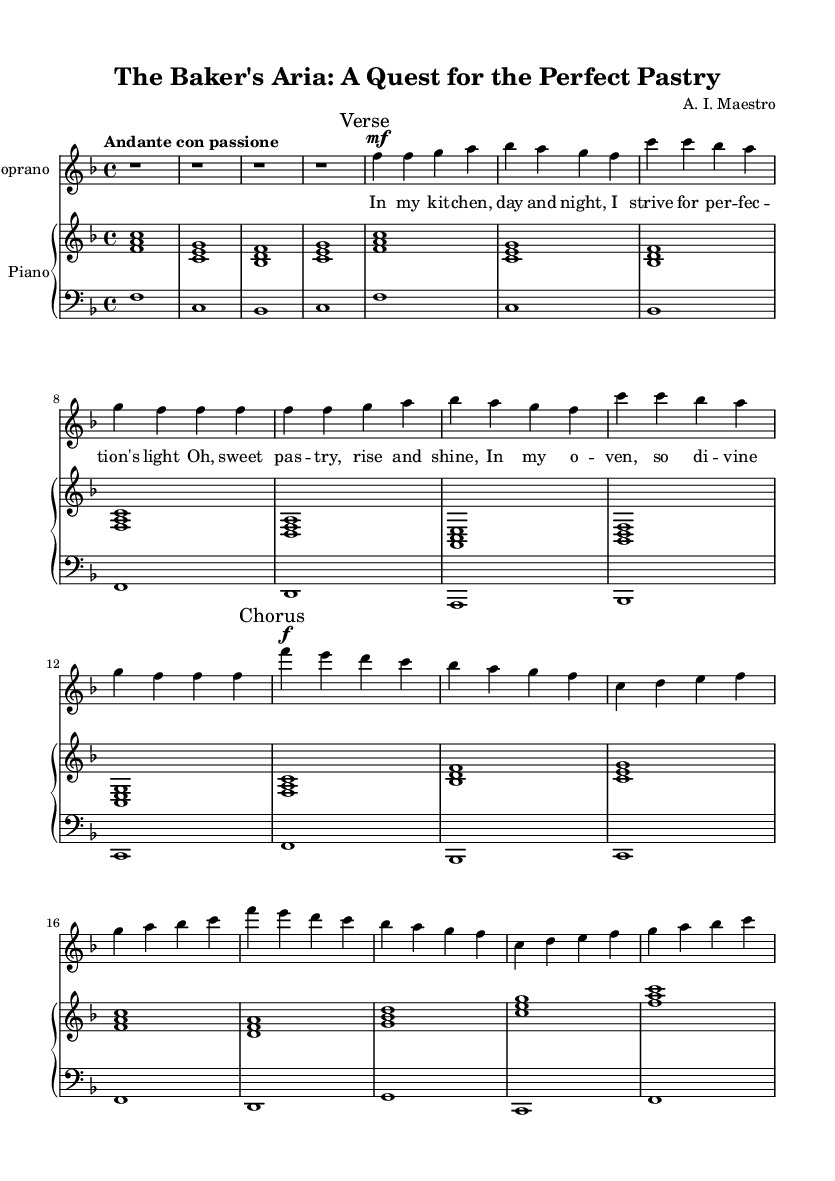What is the key signature of this music? The key signature can be found at the beginning of the sheet music, indicating F major, which has one flat (B flat).
Answer: F major What is the time signature of this music? The time signature is shown at the beginning of the piece and is indicated as 4/4, meaning there are four beats in each measure.
Answer: 4/4 What is the tempo marking of this music? The tempo marking "Andante con passione" is written above the staff, signaling that the piece should be played at a moderate speed with passion.
Answer: Andante con passione How many verses are present in the sheet music? By observing the structure of the piece, there is an indication of the Verse at the beginning of the first lyrical section, suggesting there is at least one verse.
Answer: 1 What phrase marks the beginning of the Chorus in this piece? The sheet contains a clear indication labeled "Chorus," which is marked in the music, identifying where the Chorus section starts after the first verse.
Answer: Chorus In which section does the phrase "In my kitchen, day and night" appear? This phrase is part of the lyrics, which is placed in the Verse section, as indicated in the correspondence between lyrics and musical markings.
Answer: Verse 